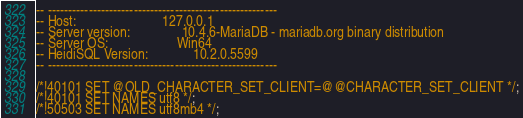Convert code to text. <code><loc_0><loc_0><loc_500><loc_500><_SQL_>-- --------------------------------------------------------
-- Host:                         127.0.0.1
-- Server version:               10.4.6-MariaDB - mariadb.org binary distribution
-- Server OS:                    Win64
-- HeidiSQL Version:             10.2.0.5599
-- --------------------------------------------------------

/*!40101 SET @OLD_CHARACTER_SET_CLIENT=@@CHARACTER_SET_CLIENT */;
/*!40101 SET NAMES utf8 */;
/*!50503 SET NAMES utf8mb4 */;</code> 